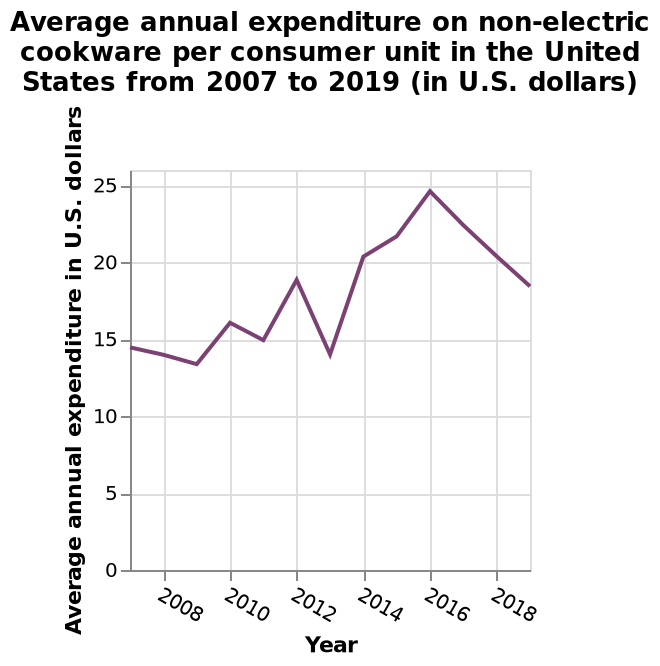<image>
In which year did the average annual expenditure on non-electric cookware per consumer unit reach its highest point?  The description does not mention the year in which the average annual expenditure on non-electric cookware per consumer unit reached its highest point. What is the average annual expenditure on non-electric cookware per consumer unit in the United States in 2019?  The average annual expenditure on non-electric cookware per consumer unit in the United States in 2019 was not provided in the description. On the y-axis, what is the value represented by the point at the middle of the scale?  On the y-axis, the value represented by the point at the middle of the scale is $12.50 (U.S. dollars). please summary the statistics and relations of the chart Since 2016, average annual expenditure on non electric cookware has decreased. average annual expenditure on non electric cookware since 2008-12 seems to increase then decrease, then increase again. 